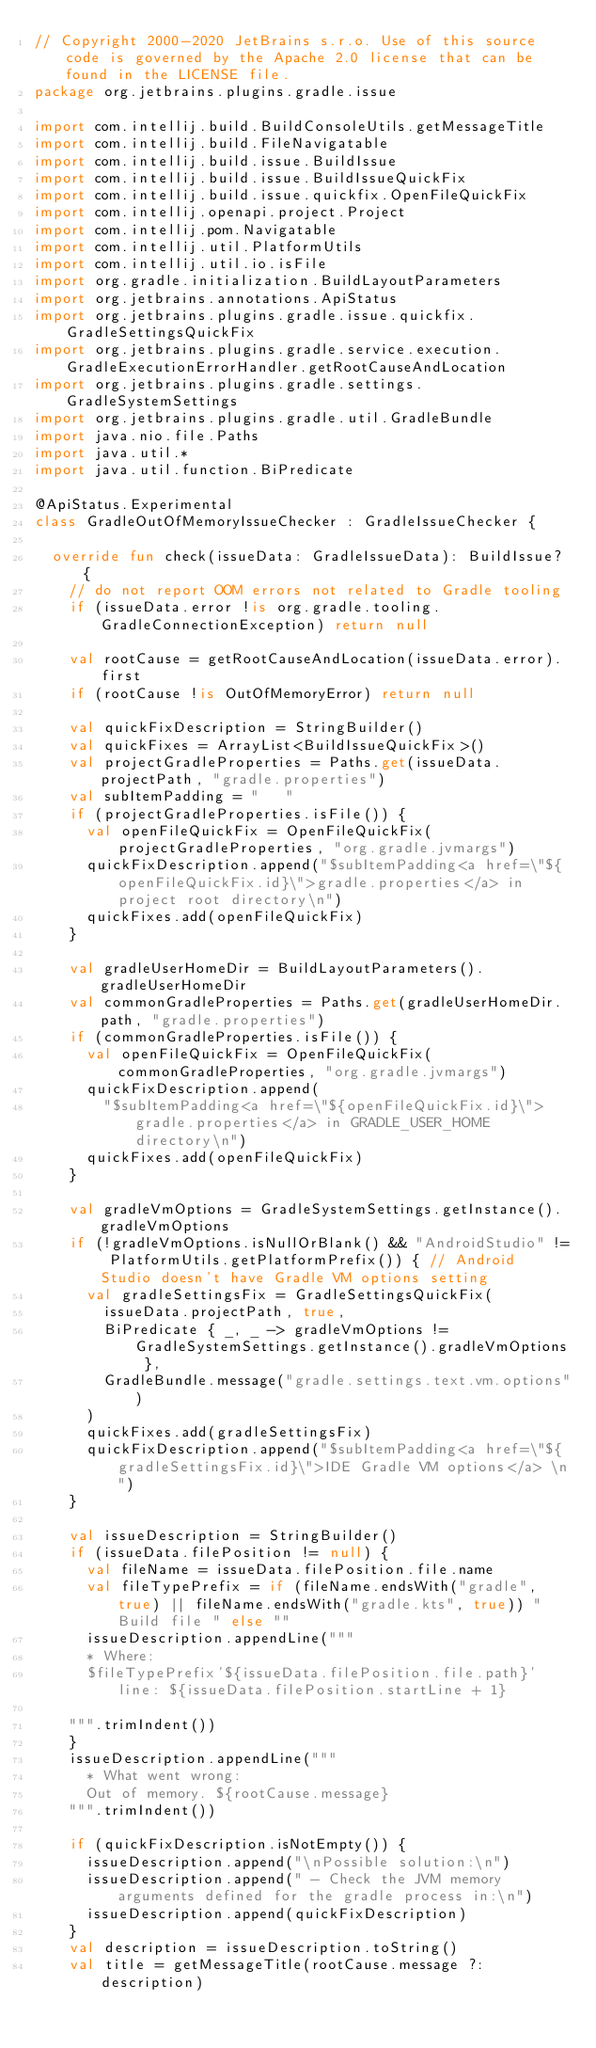<code> <loc_0><loc_0><loc_500><loc_500><_Kotlin_>// Copyright 2000-2020 JetBrains s.r.o. Use of this source code is governed by the Apache 2.0 license that can be found in the LICENSE file.
package org.jetbrains.plugins.gradle.issue

import com.intellij.build.BuildConsoleUtils.getMessageTitle
import com.intellij.build.FileNavigatable
import com.intellij.build.issue.BuildIssue
import com.intellij.build.issue.BuildIssueQuickFix
import com.intellij.build.issue.quickfix.OpenFileQuickFix
import com.intellij.openapi.project.Project
import com.intellij.pom.Navigatable
import com.intellij.util.PlatformUtils
import com.intellij.util.io.isFile
import org.gradle.initialization.BuildLayoutParameters
import org.jetbrains.annotations.ApiStatus
import org.jetbrains.plugins.gradle.issue.quickfix.GradleSettingsQuickFix
import org.jetbrains.plugins.gradle.service.execution.GradleExecutionErrorHandler.getRootCauseAndLocation
import org.jetbrains.plugins.gradle.settings.GradleSystemSettings
import org.jetbrains.plugins.gradle.util.GradleBundle
import java.nio.file.Paths
import java.util.*
import java.util.function.BiPredicate

@ApiStatus.Experimental
class GradleOutOfMemoryIssueChecker : GradleIssueChecker {

  override fun check(issueData: GradleIssueData): BuildIssue? {
    // do not report OOM errors not related to Gradle tooling
    if (issueData.error !is org.gradle.tooling.GradleConnectionException) return null

    val rootCause = getRootCauseAndLocation(issueData.error).first
    if (rootCause !is OutOfMemoryError) return null

    val quickFixDescription = StringBuilder()
    val quickFixes = ArrayList<BuildIssueQuickFix>()
    val projectGradleProperties = Paths.get(issueData.projectPath, "gradle.properties")
    val subItemPadding = "   "
    if (projectGradleProperties.isFile()) {
      val openFileQuickFix = OpenFileQuickFix(projectGradleProperties, "org.gradle.jvmargs")
      quickFixDescription.append("$subItemPadding<a href=\"${openFileQuickFix.id}\">gradle.properties</a> in project root directory\n")
      quickFixes.add(openFileQuickFix)
    }

    val gradleUserHomeDir = BuildLayoutParameters().gradleUserHomeDir
    val commonGradleProperties = Paths.get(gradleUserHomeDir.path, "gradle.properties")
    if (commonGradleProperties.isFile()) {
      val openFileQuickFix = OpenFileQuickFix(commonGradleProperties, "org.gradle.jvmargs")
      quickFixDescription.append(
        "$subItemPadding<a href=\"${openFileQuickFix.id}\">gradle.properties</a> in GRADLE_USER_HOME directory\n")
      quickFixes.add(openFileQuickFix)
    }

    val gradleVmOptions = GradleSystemSettings.getInstance().gradleVmOptions
    if (!gradleVmOptions.isNullOrBlank() && "AndroidStudio" != PlatformUtils.getPlatformPrefix()) { // Android Studio doesn't have Gradle VM options setting
      val gradleSettingsFix = GradleSettingsQuickFix(
        issueData.projectPath, true,
        BiPredicate { _, _ -> gradleVmOptions != GradleSystemSettings.getInstance().gradleVmOptions },
        GradleBundle.message("gradle.settings.text.vm.options")
      )
      quickFixes.add(gradleSettingsFix)
      quickFixDescription.append("$subItemPadding<a href=\"${gradleSettingsFix.id}\">IDE Gradle VM options</a> \n")
    }

    val issueDescription = StringBuilder()
    if (issueData.filePosition != null) {
      val fileName = issueData.filePosition.file.name
      val fileTypePrefix = if (fileName.endsWith("gradle", true) || fileName.endsWith("gradle.kts", true)) "Build file " else ""
      issueDescription.appendLine("""
      * Where:
      $fileTypePrefix'${issueData.filePosition.file.path}' line: ${issueData.filePosition.startLine + 1}

    """.trimIndent())
    }
    issueDescription.appendLine("""
      * What went wrong:
      Out of memory. ${rootCause.message}
    """.trimIndent())

    if (quickFixDescription.isNotEmpty()) {
      issueDescription.append("\nPossible solution:\n")
      issueDescription.append(" - Check the JVM memory arguments defined for the gradle process in:\n")
      issueDescription.append(quickFixDescription)
    }
    val description = issueDescription.toString()
    val title = getMessageTitle(rootCause.message ?: description)
</code> 